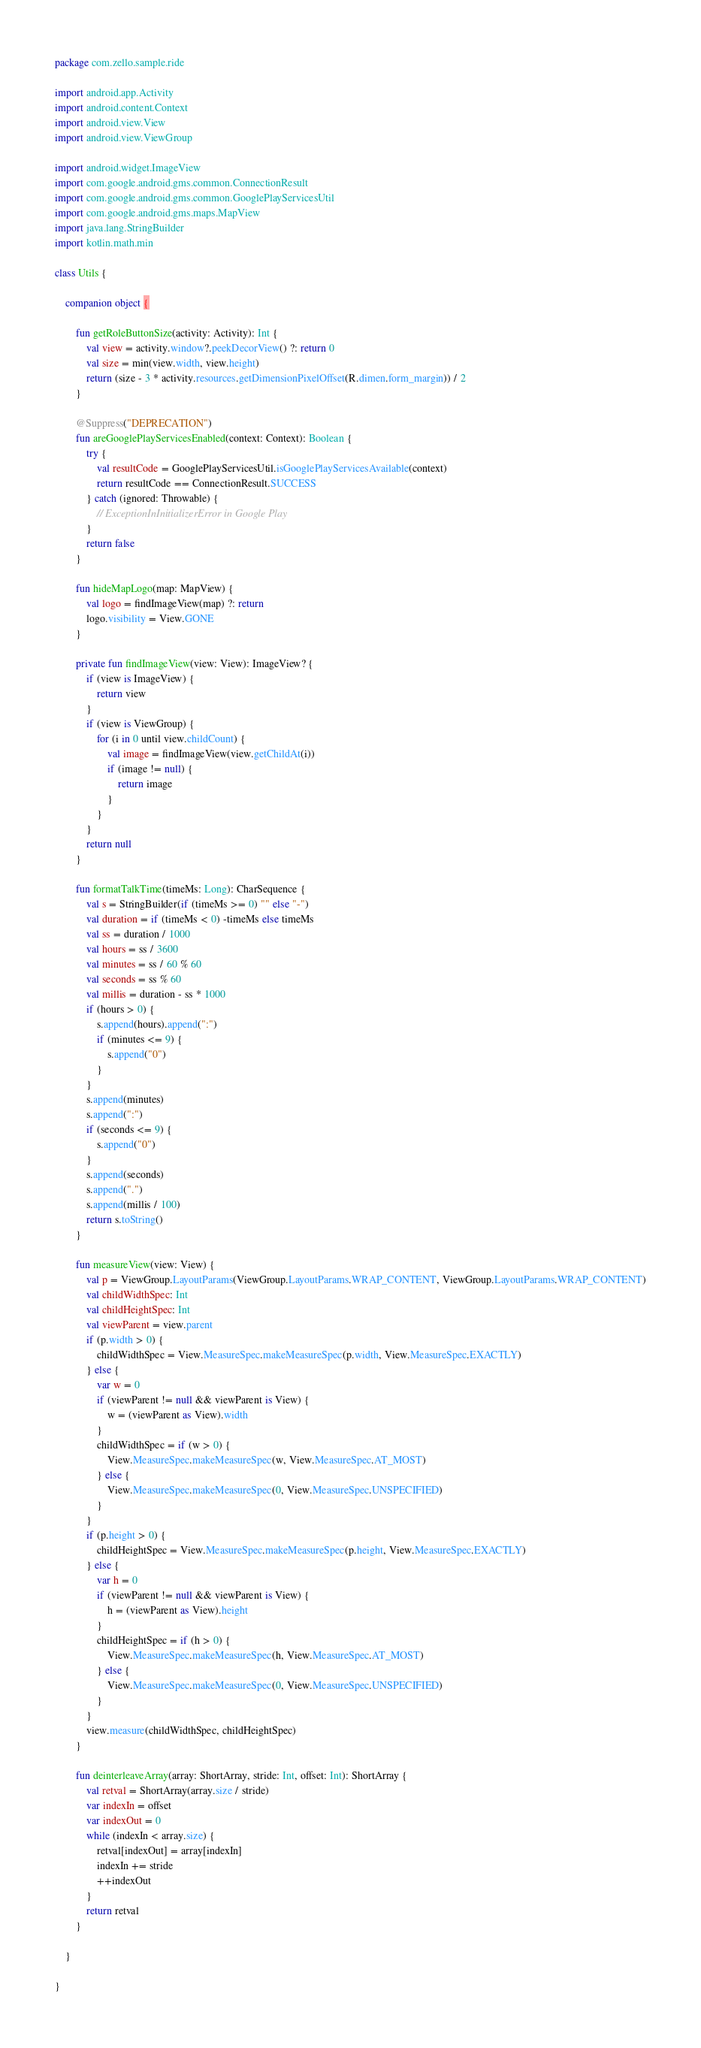<code> <loc_0><loc_0><loc_500><loc_500><_Kotlin_>package com.zello.sample.ride

import android.app.Activity
import android.content.Context
import android.view.View
import android.view.ViewGroup

import android.widget.ImageView
import com.google.android.gms.common.ConnectionResult
import com.google.android.gms.common.GooglePlayServicesUtil
import com.google.android.gms.maps.MapView
import java.lang.StringBuilder
import kotlin.math.min

class Utils {

	companion object {

		fun getRoleButtonSize(activity: Activity): Int {
			val view = activity.window?.peekDecorView() ?: return 0
			val size = min(view.width, view.height)
			return (size - 3 * activity.resources.getDimensionPixelOffset(R.dimen.form_margin)) / 2
		}

		@Suppress("DEPRECATION")
		fun areGooglePlayServicesEnabled(context: Context): Boolean {
			try {
				val resultCode = GooglePlayServicesUtil.isGooglePlayServicesAvailable(context)
				return resultCode == ConnectionResult.SUCCESS
			} catch (ignored: Throwable) {
				// ExceptionInInitializerError in Google Play
			}
			return false
		}

		fun hideMapLogo(map: MapView) {
			val logo = findImageView(map) ?: return
			logo.visibility = View.GONE
		}

		private fun findImageView(view: View): ImageView? {
			if (view is ImageView) {
				return view
			}
			if (view is ViewGroup) {
				for (i in 0 until view.childCount) {
					val image = findImageView(view.getChildAt(i))
					if (image != null) {
						return image
					}
				}
			}
			return null
		}

		fun formatTalkTime(timeMs: Long): CharSequence {
			val s = StringBuilder(if (timeMs >= 0) "" else "-")
			val duration = if (timeMs < 0) -timeMs else timeMs
			val ss = duration / 1000
			val hours = ss / 3600
			val minutes = ss / 60 % 60
			val seconds = ss % 60
			val millis = duration - ss * 1000
			if (hours > 0) {
				s.append(hours).append(":")
				if (minutes <= 9) {
					s.append("0")
				}
			}
			s.append(minutes)
			s.append(":")
			if (seconds <= 9) {
				s.append("0")
			}
			s.append(seconds)
			s.append(".")
			s.append(millis / 100)
			return s.toString()
		}

		fun measureView(view: View) {
			val p = ViewGroup.LayoutParams(ViewGroup.LayoutParams.WRAP_CONTENT, ViewGroup.LayoutParams.WRAP_CONTENT)
			val childWidthSpec: Int
			val childHeightSpec: Int
			val viewParent = view.parent
			if (p.width > 0) {
				childWidthSpec = View.MeasureSpec.makeMeasureSpec(p.width, View.MeasureSpec.EXACTLY)
			} else {
				var w = 0
				if (viewParent != null && viewParent is View) {
					w = (viewParent as View).width
				}
				childWidthSpec = if (w > 0) {
					View.MeasureSpec.makeMeasureSpec(w, View.MeasureSpec.AT_MOST)
				} else {
					View.MeasureSpec.makeMeasureSpec(0, View.MeasureSpec.UNSPECIFIED)
				}
			}
			if (p.height > 0) {
				childHeightSpec = View.MeasureSpec.makeMeasureSpec(p.height, View.MeasureSpec.EXACTLY)
			} else {
				var h = 0
				if (viewParent != null && viewParent is View) {
					h = (viewParent as View).height
				}
				childHeightSpec = if (h > 0) {
					View.MeasureSpec.makeMeasureSpec(h, View.MeasureSpec.AT_MOST)
				} else {
					View.MeasureSpec.makeMeasureSpec(0, View.MeasureSpec.UNSPECIFIED)
				}
			}
			view.measure(childWidthSpec, childHeightSpec)
		}

		fun deinterleaveArray(array: ShortArray, stride: Int, offset: Int): ShortArray {
			val retval = ShortArray(array.size / stride)
			var indexIn = offset
			var indexOut = 0
			while (indexIn < array.size) {
				retval[indexOut] = array[indexIn]
				indexIn += stride
				++indexOut
			}
			return retval
		}

	}

}
</code> 